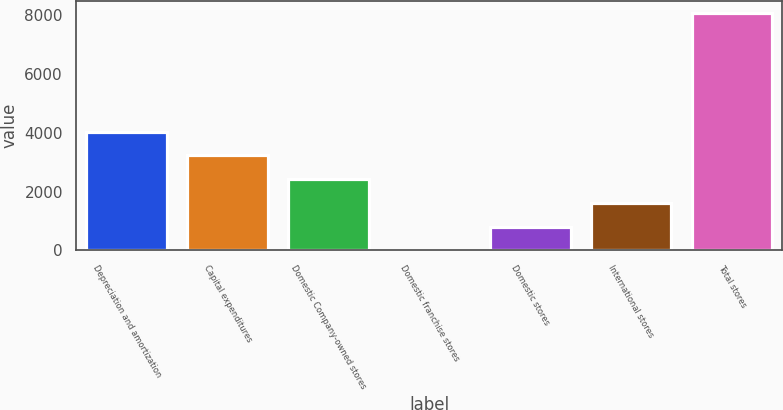Convert chart. <chart><loc_0><loc_0><loc_500><loc_500><bar_chart><fcel>Depreciation and amortization<fcel>Capital expenditures<fcel>Domestic Company-owned stores<fcel>Domestic franchise stores<fcel>Domestic stores<fcel>International stores<fcel>Total stores<nl><fcel>4041.8<fcel>3234.36<fcel>2426.92<fcel>4.6<fcel>812.04<fcel>1619.48<fcel>8079<nl></chart> 